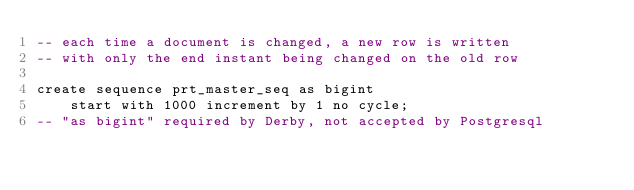Convert code to text. <code><loc_0><loc_0><loc_500><loc_500><_SQL_>-- each time a document is changed, a new row is written
-- with only the end instant being changed on the old row

create sequence prt_master_seq as bigint
    start with 1000 increment by 1 no cycle;
-- "as bigint" required by Derby, not accepted by Postgresql
</code> 